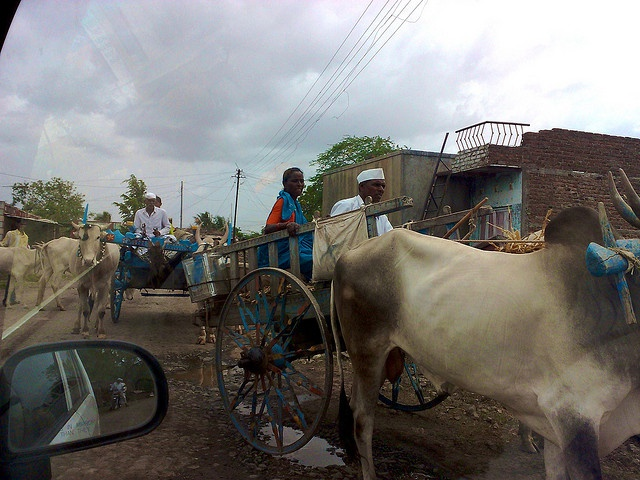Describe the objects in this image and their specific colors. I can see cow in black, gray, and darkgray tones, car in black, gray, and teal tones, cow in black and gray tones, people in black, blue, and maroon tones, and cow in black and gray tones in this image. 